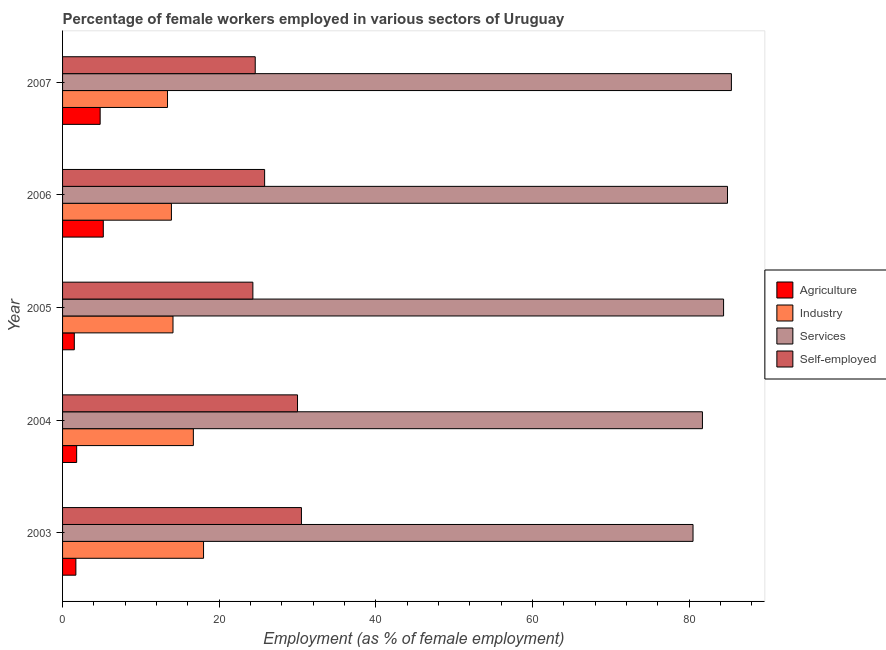How many groups of bars are there?
Offer a very short reply. 5. Are the number of bars per tick equal to the number of legend labels?
Keep it short and to the point. Yes. How many bars are there on the 1st tick from the bottom?
Your answer should be very brief. 4. What is the label of the 1st group of bars from the top?
Ensure brevity in your answer.  2007. In how many cases, is the number of bars for a given year not equal to the number of legend labels?
Make the answer very short. 0. What is the percentage of female workers in services in 2006?
Your answer should be very brief. 84.9. Across all years, what is the maximum percentage of self employed female workers?
Provide a succinct answer. 30.5. In which year was the percentage of female workers in agriculture maximum?
Ensure brevity in your answer.  2006. What is the total percentage of female workers in industry in the graph?
Your response must be concise. 76.1. What is the difference between the percentage of self employed female workers in 2003 and the percentage of female workers in industry in 2004?
Provide a succinct answer. 13.8. What is the average percentage of female workers in agriculture per year?
Your response must be concise. 3. In the year 2006, what is the difference between the percentage of female workers in agriculture and percentage of female workers in services?
Provide a short and direct response. -79.7. In how many years, is the percentage of female workers in industry greater than 56 %?
Offer a very short reply. 0. What is the ratio of the percentage of female workers in industry in 2004 to that in 2006?
Offer a terse response. 1.2. Is the difference between the percentage of female workers in services in 2003 and 2007 greater than the difference between the percentage of self employed female workers in 2003 and 2007?
Your answer should be very brief. No. What is the difference between the highest and the second highest percentage of female workers in agriculture?
Provide a short and direct response. 0.4. What is the difference between the highest and the lowest percentage of female workers in agriculture?
Give a very brief answer. 3.7. Is the sum of the percentage of female workers in services in 2004 and 2006 greater than the maximum percentage of self employed female workers across all years?
Your answer should be very brief. Yes. Is it the case that in every year, the sum of the percentage of female workers in industry and percentage of female workers in services is greater than the sum of percentage of female workers in agriculture and percentage of self employed female workers?
Offer a very short reply. Yes. What does the 2nd bar from the top in 2004 represents?
Ensure brevity in your answer.  Services. What does the 3rd bar from the bottom in 2007 represents?
Offer a very short reply. Services. Is it the case that in every year, the sum of the percentage of female workers in agriculture and percentage of female workers in industry is greater than the percentage of female workers in services?
Provide a short and direct response. No. How many bars are there?
Provide a short and direct response. 20. Are all the bars in the graph horizontal?
Make the answer very short. Yes. What is the difference between two consecutive major ticks on the X-axis?
Give a very brief answer. 20. Are the values on the major ticks of X-axis written in scientific E-notation?
Offer a very short reply. No. How many legend labels are there?
Keep it short and to the point. 4. What is the title of the graph?
Give a very brief answer. Percentage of female workers employed in various sectors of Uruguay. Does "Trade" appear as one of the legend labels in the graph?
Your answer should be compact. No. What is the label or title of the X-axis?
Ensure brevity in your answer.  Employment (as % of female employment). What is the label or title of the Y-axis?
Your response must be concise. Year. What is the Employment (as % of female employment) of Agriculture in 2003?
Provide a succinct answer. 1.7. What is the Employment (as % of female employment) of Services in 2003?
Give a very brief answer. 80.5. What is the Employment (as % of female employment) of Self-employed in 2003?
Provide a short and direct response. 30.5. What is the Employment (as % of female employment) in Agriculture in 2004?
Make the answer very short. 1.8. What is the Employment (as % of female employment) in Industry in 2004?
Your answer should be compact. 16.7. What is the Employment (as % of female employment) of Services in 2004?
Give a very brief answer. 81.7. What is the Employment (as % of female employment) of Self-employed in 2004?
Your answer should be compact. 30. What is the Employment (as % of female employment) of Industry in 2005?
Make the answer very short. 14.1. What is the Employment (as % of female employment) in Services in 2005?
Your response must be concise. 84.4. What is the Employment (as % of female employment) in Self-employed in 2005?
Provide a short and direct response. 24.3. What is the Employment (as % of female employment) of Agriculture in 2006?
Offer a terse response. 5.2. What is the Employment (as % of female employment) of Industry in 2006?
Make the answer very short. 13.9. What is the Employment (as % of female employment) of Services in 2006?
Offer a very short reply. 84.9. What is the Employment (as % of female employment) in Self-employed in 2006?
Offer a terse response. 25.8. What is the Employment (as % of female employment) in Agriculture in 2007?
Provide a succinct answer. 4.8. What is the Employment (as % of female employment) of Industry in 2007?
Provide a short and direct response. 13.4. What is the Employment (as % of female employment) of Services in 2007?
Your answer should be very brief. 85.4. What is the Employment (as % of female employment) of Self-employed in 2007?
Keep it short and to the point. 24.6. Across all years, what is the maximum Employment (as % of female employment) of Agriculture?
Offer a terse response. 5.2. Across all years, what is the maximum Employment (as % of female employment) of Services?
Your answer should be very brief. 85.4. Across all years, what is the maximum Employment (as % of female employment) in Self-employed?
Offer a terse response. 30.5. Across all years, what is the minimum Employment (as % of female employment) of Agriculture?
Ensure brevity in your answer.  1.5. Across all years, what is the minimum Employment (as % of female employment) of Industry?
Your answer should be very brief. 13.4. Across all years, what is the minimum Employment (as % of female employment) in Services?
Provide a succinct answer. 80.5. Across all years, what is the minimum Employment (as % of female employment) in Self-employed?
Your response must be concise. 24.3. What is the total Employment (as % of female employment) of Agriculture in the graph?
Make the answer very short. 15. What is the total Employment (as % of female employment) in Industry in the graph?
Provide a short and direct response. 76.1. What is the total Employment (as % of female employment) in Services in the graph?
Offer a terse response. 416.9. What is the total Employment (as % of female employment) of Self-employed in the graph?
Your response must be concise. 135.2. What is the difference between the Employment (as % of female employment) of Agriculture in 2003 and that in 2004?
Your answer should be compact. -0.1. What is the difference between the Employment (as % of female employment) in Industry in 2003 and that in 2004?
Offer a very short reply. 1.3. What is the difference between the Employment (as % of female employment) in Services in 2003 and that in 2004?
Give a very brief answer. -1.2. What is the difference between the Employment (as % of female employment) in Self-employed in 2003 and that in 2004?
Your response must be concise. 0.5. What is the difference between the Employment (as % of female employment) in Agriculture in 2003 and that in 2005?
Your answer should be very brief. 0.2. What is the difference between the Employment (as % of female employment) in Self-employed in 2003 and that in 2005?
Give a very brief answer. 6.2. What is the difference between the Employment (as % of female employment) in Industry in 2003 and that in 2006?
Make the answer very short. 4.1. What is the difference between the Employment (as % of female employment) of Services in 2003 and that in 2006?
Provide a succinct answer. -4.4. What is the difference between the Employment (as % of female employment) of Self-employed in 2003 and that in 2006?
Offer a very short reply. 4.7. What is the difference between the Employment (as % of female employment) of Industry in 2003 and that in 2007?
Your answer should be compact. 4.6. What is the difference between the Employment (as % of female employment) in Services in 2003 and that in 2007?
Your answer should be compact. -4.9. What is the difference between the Employment (as % of female employment) of Self-employed in 2003 and that in 2007?
Offer a terse response. 5.9. What is the difference between the Employment (as % of female employment) of Self-employed in 2004 and that in 2005?
Ensure brevity in your answer.  5.7. What is the difference between the Employment (as % of female employment) of Industry in 2004 and that in 2006?
Provide a short and direct response. 2.8. What is the difference between the Employment (as % of female employment) in Services in 2004 and that in 2006?
Make the answer very short. -3.2. What is the difference between the Employment (as % of female employment) in Self-employed in 2004 and that in 2006?
Make the answer very short. 4.2. What is the difference between the Employment (as % of female employment) of Industry in 2004 and that in 2007?
Offer a very short reply. 3.3. What is the difference between the Employment (as % of female employment) of Industry in 2005 and that in 2006?
Offer a very short reply. 0.2. What is the difference between the Employment (as % of female employment) in Services in 2005 and that in 2006?
Offer a very short reply. -0.5. What is the difference between the Employment (as % of female employment) of Self-employed in 2005 and that in 2006?
Your answer should be very brief. -1.5. What is the difference between the Employment (as % of female employment) in Industry in 2005 and that in 2007?
Make the answer very short. 0.7. What is the difference between the Employment (as % of female employment) of Services in 2005 and that in 2007?
Keep it short and to the point. -1. What is the difference between the Employment (as % of female employment) of Self-employed in 2005 and that in 2007?
Keep it short and to the point. -0.3. What is the difference between the Employment (as % of female employment) in Agriculture in 2006 and that in 2007?
Give a very brief answer. 0.4. What is the difference between the Employment (as % of female employment) of Industry in 2006 and that in 2007?
Offer a terse response. 0.5. What is the difference between the Employment (as % of female employment) in Services in 2006 and that in 2007?
Keep it short and to the point. -0.5. What is the difference between the Employment (as % of female employment) in Agriculture in 2003 and the Employment (as % of female employment) in Industry in 2004?
Make the answer very short. -15. What is the difference between the Employment (as % of female employment) in Agriculture in 2003 and the Employment (as % of female employment) in Services in 2004?
Keep it short and to the point. -80. What is the difference between the Employment (as % of female employment) in Agriculture in 2003 and the Employment (as % of female employment) in Self-employed in 2004?
Make the answer very short. -28.3. What is the difference between the Employment (as % of female employment) in Industry in 2003 and the Employment (as % of female employment) in Services in 2004?
Offer a terse response. -63.7. What is the difference between the Employment (as % of female employment) of Services in 2003 and the Employment (as % of female employment) of Self-employed in 2004?
Ensure brevity in your answer.  50.5. What is the difference between the Employment (as % of female employment) of Agriculture in 2003 and the Employment (as % of female employment) of Industry in 2005?
Offer a terse response. -12.4. What is the difference between the Employment (as % of female employment) of Agriculture in 2003 and the Employment (as % of female employment) of Services in 2005?
Make the answer very short. -82.7. What is the difference between the Employment (as % of female employment) of Agriculture in 2003 and the Employment (as % of female employment) of Self-employed in 2005?
Your answer should be very brief. -22.6. What is the difference between the Employment (as % of female employment) in Industry in 2003 and the Employment (as % of female employment) in Services in 2005?
Give a very brief answer. -66.4. What is the difference between the Employment (as % of female employment) of Services in 2003 and the Employment (as % of female employment) of Self-employed in 2005?
Give a very brief answer. 56.2. What is the difference between the Employment (as % of female employment) in Agriculture in 2003 and the Employment (as % of female employment) in Services in 2006?
Keep it short and to the point. -83.2. What is the difference between the Employment (as % of female employment) in Agriculture in 2003 and the Employment (as % of female employment) in Self-employed in 2006?
Offer a very short reply. -24.1. What is the difference between the Employment (as % of female employment) in Industry in 2003 and the Employment (as % of female employment) in Services in 2006?
Offer a terse response. -66.9. What is the difference between the Employment (as % of female employment) in Services in 2003 and the Employment (as % of female employment) in Self-employed in 2006?
Make the answer very short. 54.7. What is the difference between the Employment (as % of female employment) of Agriculture in 2003 and the Employment (as % of female employment) of Industry in 2007?
Provide a succinct answer. -11.7. What is the difference between the Employment (as % of female employment) in Agriculture in 2003 and the Employment (as % of female employment) in Services in 2007?
Your answer should be very brief. -83.7. What is the difference between the Employment (as % of female employment) in Agriculture in 2003 and the Employment (as % of female employment) in Self-employed in 2007?
Your answer should be compact. -22.9. What is the difference between the Employment (as % of female employment) in Industry in 2003 and the Employment (as % of female employment) in Services in 2007?
Offer a terse response. -67.4. What is the difference between the Employment (as % of female employment) in Services in 2003 and the Employment (as % of female employment) in Self-employed in 2007?
Offer a very short reply. 55.9. What is the difference between the Employment (as % of female employment) in Agriculture in 2004 and the Employment (as % of female employment) in Industry in 2005?
Your answer should be very brief. -12.3. What is the difference between the Employment (as % of female employment) of Agriculture in 2004 and the Employment (as % of female employment) of Services in 2005?
Make the answer very short. -82.6. What is the difference between the Employment (as % of female employment) in Agriculture in 2004 and the Employment (as % of female employment) in Self-employed in 2005?
Make the answer very short. -22.5. What is the difference between the Employment (as % of female employment) in Industry in 2004 and the Employment (as % of female employment) in Services in 2005?
Provide a short and direct response. -67.7. What is the difference between the Employment (as % of female employment) in Industry in 2004 and the Employment (as % of female employment) in Self-employed in 2005?
Your response must be concise. -7.6. What is the difference between the Employment (as % of female employment) in Services in 2004 and the Employment (as % of female employment) in Self-employed in 2005?
Ensure brevity in your answer.  57.4. What is the difference between the Employment (as % of female employment) of Agriculture in 2004 and the Employment (as % of female employment) of Industry in 2006?
Ensure brevity in your answer.  -12.1. What is the difference between the Employment (as % of female employment) in Agriculture in 2004 and the Employment (as % of female employment) in Services in 2006?
Provide a short and direct response. -83.1. What is the difference between the Employment (as % of female employment) in Industry in 2004 and the Employment (as % of female employment) in Services in 2006?
Your response must be concise. -68.2. What is the difference between the Employment (as % of female employment) of Industry in 2004 and the Employment (as % of female employment) of Self-employed in 2006?
Your answer should be very brief. -9.1. What is the difference between the Employment (as % of female employment) in Services in 2004 and the Employment (as % of female employment) in Self-employed in 2006?
Offer a terse response. 55.9. What is the difference between the Employment (as % of female employment) in Agriculture in 2004 and the Employment (as % of female employment) in Services in 2007?
Provide a succinct answer. -83.6. What is the difference between the Employment (as % of female employment) of Agriculture in 2004 and the Employment (as % of female employment) of Self-employed in 2007?
Provide a succinct answer. -22.8. What is the difference between the Employment (as % of female employment) of Industry in 2004 and the Employment (as % of female employment) of Services in 2007?
Ensure brevity in your answer.  -68.7. What is the difference between the Employment (as % of female employment) of Services in 2004 and the Employment (as % of female employment) of Self-employed in 2007?
Give a very brief answer. 57.1. What is the difference between the Employment (as % of female employment) in Agriculture in 2005 and the Employment (as % of female employment) in Industry in 2006?
Provide a short and direct response. -12.4. What is the difference between the Employment (as % of female employment) of Agriculture in 2005 and the Employment (as % of female employment) of Services in 2006?
Offer a very short reply. -83.4. What is the difference between the Employment (as % of female employment) in Agriculture in 2005 and the Employment (as % of female employment) in Self-employed in 2006?
Your response must be concise. -24.3. What is the difference between the Employment (as % of female employment) in Industry in 2005 and the Employment (as % of female employment) in Services in 2006?
Give a very brief answer. -70.8. What is the difference between the Employment (as % of female employment) of Industry in 2005 and the Employment (as % of female employment) of Self-employed in 2006?
Make the answer very short. -11.7. What is the difference between the Employment (as % of female employment) in Services in 2005 and the Employment (as % of female employment) in Self-employed in 2006?
Provide a short and direct response. 58.6. What is the difference between the Employment (as % of female employment) in Agriculture in 2005 and the Employment (as % of female employment) in Services in 2007?
Offer a very short reply. -83.9. What is the difference between the Employment (as % of female employment) of Agriculture in 2005 and the Employment (as % of female employment) of Self-employed in 2007?
Offer a very short reply. -23.1. What is the difference between the Employment (as % of female employment) of Industry in 2005 and the Employment (as % of female employment) of Services in 2007?
Your response must be concise. -71.3. What is the difference between the Employment (as % of female employment) in Industry in 2005 and the Employment (as % of female employment) in Self-employed in 2007?
Ensure brevity in your answer.  -10.5. What is the difference between the Employment (as % of female employment) of Services in 2005 and the Employment (as % of female employment) of Self-employed in 2007?
Your answer should be compact. 59.8. What is the difference between the Employment (as % of female employment) of Agriculture in 2006 and the Employment (as % of female employment) of Industry in 2007?
Ensure brevity in your answer.  -8.2. What is the difference between the Employment (as % of female employment) in Agriculture in 2006 and the Employment (as % of female employment) in Services in 2007?
Provide a succinct answer. -80.2. What is the difference between the Employment (as % of female employment) of Agriculture in 2006 and the Employment (as % of female employment) of Self-employed in 2007?
Give a very brief answer. -19.4. What is the difference between the Employment (as % of female employment) of Industry in 2006 and the Employment (as % of female employment) of Services in 2007?
Offer a very short reply. -71.5. What is the difference between the Employment (as % of female employment) of Services in 2006 and the Employment (as % of female employment) of Self-employed in 2007?
Offer a very short reply. 60.3. What is the average Employment (as % of female employment) of Industry per year?
Make the answer very short. 15.22. What is the average Employment (as % of female employment) of Services per year?
Your answer should be compact. 83.38. What is the average Employment (as % of female employment) of Self-employed per year?
Make the answer very short. 27.04. In the year 2003, what is the difference between the Employment (as % of female employment) in Agriculture and Employment (as % of female employment) in Industry?
Keep it short and to the point. -16.3. In the year 2003, what is the difference between the Employment (as % of female employment) in Agriculture and Employment (as % of female employment) in Services?
Provide a succinct answer. -78.8. In the year 2003, what is the difference between the Employment (as % of female employment) in Agriculture and Employment (as % of female employment) in Self-employed?
Offer a very short reply. -28.8. In the year 2003, what is the difference between the Employment (as % of female employment) of Industry and Employment (as % of female employment) of Services?
Provide a short and direct response. -62.5. In the year 2003, what is the difference between the Employment (as % of female employment) in Services and Employment (as % of female employment) in Self-employed?
Keep it short and to the point. 50. In the year 2004, what is the difference between the Employment (as % of female employment) in Agriculture and Employment (as % of female employment) in Industry?
Keep it short and to the point. -14.9. In the year 2004, what is the difference between the Employment (as % of female employment) in Agriculture and Employment (as % of female employment) in Services?
Offer a terse response. -79.9. In the year 2004, what is the difference between the Employment (as % of female employment) of Agriculture and Employment (as % of female employment) of Self-employed?
Make the answer very short. -28.2. In the year 2004, what is the difference between the Employment (as % of female employment) in Industry and Employment (as % of female employment) in Services?
Your response must be concise. -65. In the year 2004, what is the difference between the Employment (as % of female employment) of Services and Employment (as % of female employment) of Self-employed?
Provide a succinct answer. 51.7. In the year 2005, what is the difference between the Employment (as % of female employment) in Agriculture and Employment (as % of female employment) in Services?
Provide a short and direct response. -82.9. In the year 2005, what is the difference between the Employment (as % of female employment) in Agriculture and Employment (as % of female employment) in Self-employed?
Your response must be concise. -22.8. In the year 2005, what is the difference between the Employment (as % of female employment) in Industry and Employment (as % of female employment) in Services?
Provide a short and direct response. -70.3. In the year 2005, what is the difference between the Employment (as % of female employment) in Industry and Employment (as % of female employment) in Self-employed?
Provide a short and direct response. -10.2. In the year 2005, what is the difference between the Employment (as % of female employment) in Services and Employment (as % of female employment) in Self-employed?
Offer a very short reply. 60.1. In the year 2006, what is the difference between the Employment (as % of female employment) in Agriculture and Employment (as % of female employment) in Industry?
Your answer should be compact. -8.7. In the year 2006, what is the difference between the Employment (as % of female employment) in Agriculture and Employment (as % of female employment) in Services?
Make the answer very short. -79.7. In the year 2006, what is the difference between the Employment (as % of female employment) in Agriculture and Employment (as % of female employment) in Self-employed?
Offer a very short reply. -20.6. In the year 2006, what is the difference between the Employment (as % of female employment) of Industry and Employment (as % of female employment) of Services?
Give a very brief answer. -71. In the year 2006, what is the difference between the Employment (as % of female employment) of Services and Employment (as % of female employment) of Self-employed?
Make the answer very short. 59.1. In the year 2007, what is the difference between the Employment (as % of female employment) of Agriculture and Employment (as % of female employment) of Industry?
Provide a short and direct response. -8.6. In the year 2007, what is the difference between the Employment (as % of female employment) in Agriculture and Employment (as % of female employment) in Services?
Your answer should be compact. -80.6. In the year 2007, what is the difference between the Employment (as % of female employment) in Agriculture and Employment (as % of female employment) in Self-employed?
Provide a succinct answer. -19.8. In the year 2007, what is the difference between the Employment (as % of female employment) of Industry and Employment (as % of female employment) of Services?
Make the answer very short. -72. In the year 2007, what is the difference between the Employment (as % of female employment) in Industry and Employment (as % of female employment) in Self-employed?
Make the answer very short. -11.2. In the year 2007, what is the difference between the Employment (as % of female employment) in Services and Employment (as % of female employment) in Self-employed?
Your response must be concise. 60.8. What is the ratio of the Employment (as % of female employment) in Agriculture in 2003 to that in 2004?
Provide a succinct answer. 0.94. What is the ratio of the Employment (as % of female employment) in Industry in 2003 to that in 2004?
Give a very brief answer. 1.08. What is the ratio of the Employment (as % of female employment) in Self-employed in 2003 to that in 2004?
Offer a very short reply. 1.02. What is the ratio of the Employment (as % of female employment) of Agriculture in 2003 to that in 2005?
Give a very brief answer. 1.13. What is the ratio of the Employment (as % of female employment) in Industry in 2003 to that in 2005?
Offer a very short reply. 1.28. What is the ratio of the Employment (as % of female employment) in Services in 2003 to that in 2005?
Keep it short and to the point. 0.95. What is the ratio of the Employment (as % of female employment) in Self-employed in 2003 to that in 2005?
Your answer should be very brief. 1.26. What is the ratio of the Employment (as % of female employment) in Agriculture in 2003 to that in 2006?
Your answer should be very brief. 0.33. What is the ratio of the Employment (as % of female employment) in Industry in 2003 to that in 2006?
Provide a succinct answer. 1.29. What is the ratio of the Employment (as % of female employment) in Services in 2003 to that in 2006?
Keep it short and to the point. 0.95. What is the ratio of the Employment (as % of female employment) in Self-employed in 2003 to that in 2006?
Provide a succinct answer. 1.18. What is the ratio of the Employment (as % of female employment) of Agriculture in 2003 to that in 2007?
Provide a short and direct response. 0.35. What is the ratio of the Employment (as % of female employment) in Industry in 2003 to that in 2007?
Make the answer very short. 1.34. What is the ratio of the Employment (as % of female employment) in Services in 2003 to that in 2007?
Your answer should be compact. 0.94. What is the ratio of the Employment (as % of female employment) in Self-employed in 2003 to that in 2007?
Your response must be concise. 1.24. What is the ratio of the Employment (as % of female employment) of Industry in 2004 to that in 2005?
Provide a short and direct response. 1.18. What is the ratio of the Employment (as % of female employment) in Services in 2004 to that in 2005?
Your answer should be very brief. 0.97. What is the ratio of the Employment (as % of female employment) in Self-employed in 2004 to that in 2005?
Provide a short and direct response. 1.23. What is the ratio of the Employment (as % of female employment) in Agriculture in 2004 to that in 2006?
Provide a short and direct response. 0.35. What is the ratio of the Employment (as % of female employment) of Industry in 2004 to that in 2006?
Ensure brevity in your answer.  1.2. What is the ratio of the Employment (as % of female employment) in Services in 2004 to that in 2006?
Provide a short and direct response. 0.96. What is the ratio of the Employment (as % of female employment) of Self-employed in 2004 to that in 2006?
Your answer should be very brief. 1.16. What is the ratio of the Employment (as % of female employment) in Industry in 2004 to that in 2007?
Make the answer very short. 1.25. What is the ratio of the Employment (as % of female employment) of Services in 2004 to that in 2007?
Ensure brevity in your answer.  0.96. What is the ratio of the Employment (as % of female employment) of Self-employed in 2004 to that in 2007?
Keep it short and to the point. 1.22. What is the ratio of the Employment (as % of female employment) in Agriculture in 2005 to that in 2006?
Ensure brevity in your answer.  0.29. What is the ratio of the Employment (as % of female employment) in Industry in 2005 to that in 2006?
Keep it short and to the point. 1.01. What is the ratio of the Employment (as % of female employment) in Services in 2005 to that in 2006?
Your response must be concise. 0.99. What is the ratio of the Employment (as % of female employment) of Self-employed in 2005 to that in 2006?
Your answer should be compact. 0.94. What is the ratio of the Employment (as % of female employment) in Agriculture in 2005 to that in 2007?
Provide a succinct answer. 0.31. What is the ratio of the Employment (as % of female employment) in Industry in 2005 to that in 2007?
Give a very brief answer. 1.05. What is the ratio of the Employment (as % of female employment) in Services in 2005 to that in 2007?
Offer a very short reply. 0.99. What is the ratio of the Employment (as % of female employment) in Industry in 2006 to that in 2007?
Keep it short and to the point. 1.04. What is the ratio of the Employment (as % of female employment) of Services in 2006 to that in 2007?
Provide a succinct answer. 0.99. What is the ratio of the Employment (as % of female employment) of Self-employed in 2006 to that in 2007?
Keep it short and to the point. 1.05. What is the difference between the highest and the second highest Employment (as % of female employment) of Industry?
Ensure brevity in your answer.  1.3. What is the difference between the highest and the second highest Employment (as % of female employment) in Services?
Keep it short and to the point. 0.5. What is the difference between the highest and the lowest Employment (as % of female employment) in Agriculture?
Your answer should be very brief. 3.7. What is the difference between the highest and the lowest Employment (as % of female employment) of Services?
Keep it short and to the point. 4.9. What is the difference between the highest and the lowest Employment (as % of female employment) in Self-employed?
Make the answer very short. 6.2. 